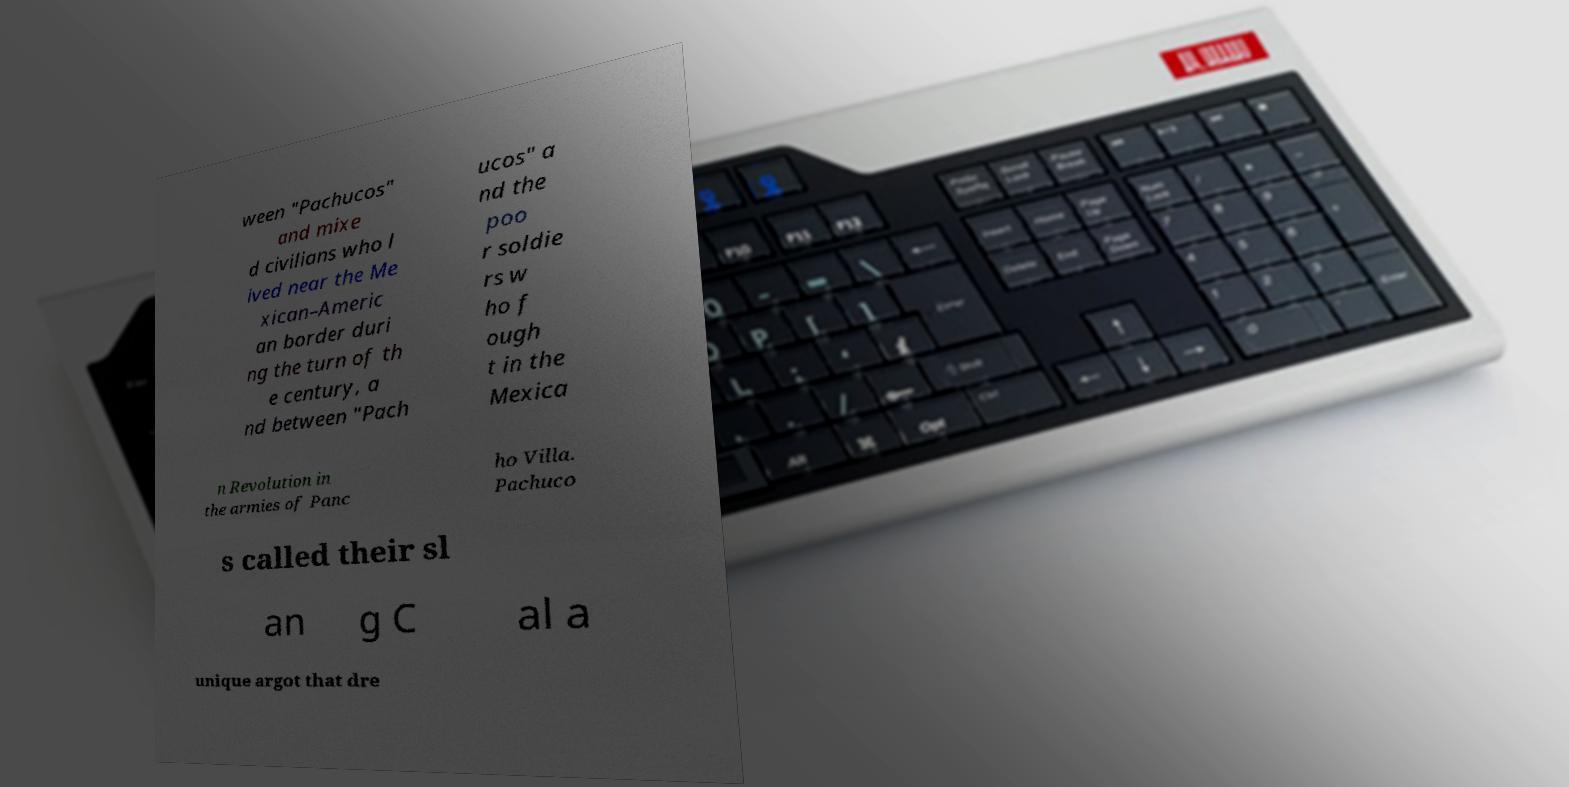Please identify and transcribe the text found in this image. ween "Pachucos" and mixe d civilians who l ived near the Me xican–Americ an border duri ng the turn of th e century, a nd between "Pach ucos" a nd the poo r soldie rs w ho f ough t in the Mexica n Revolution in the armies of Panc ho Villa. Pachuco s called their sl an g C al a unique argot that dre 